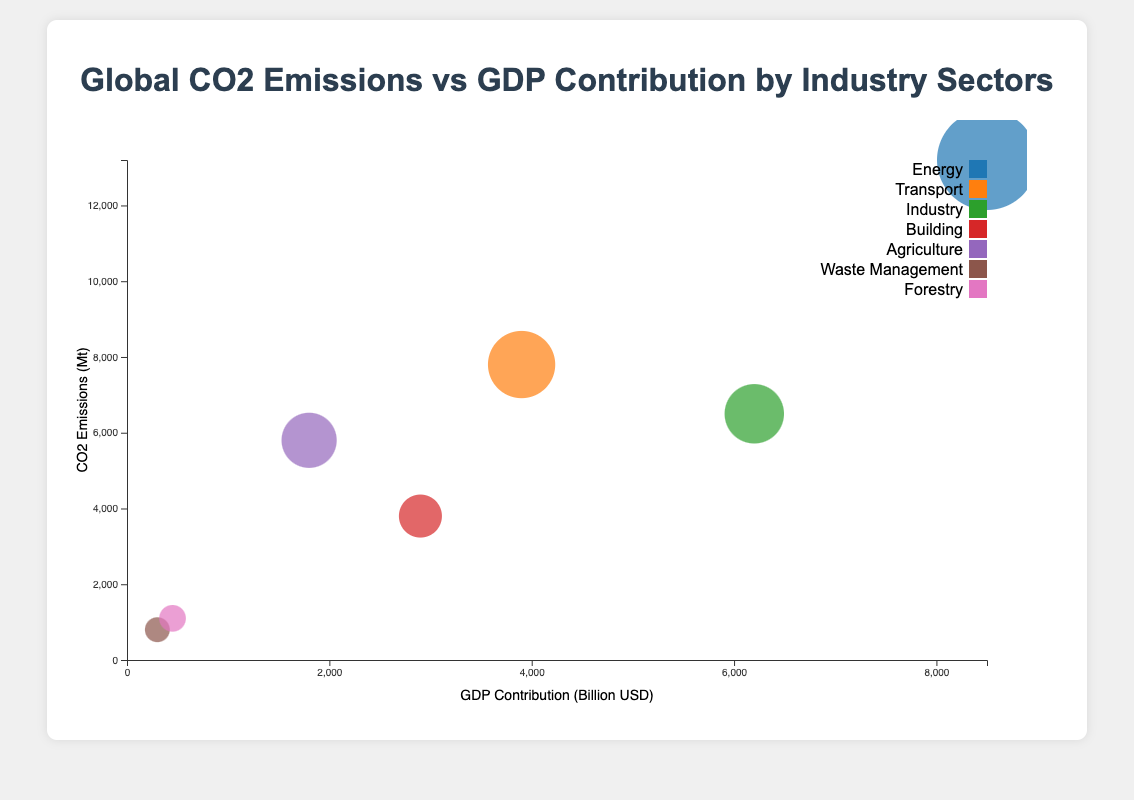What sector has the highest CO2 emissions? The sector with the highest bubble (circle) on the vertical axis represents the sector with the highest CO2 emissions. From the chart, we can see that the "Energy" sector has the highest bubble on the y-axis.
Answer: Energy What is the GDP contribution of the sector with the lowest CO2 emissions? The sector with the smallest bubble on the vertical axis represents the sector with the lowest CO2 emissions. From the chart, the "Waste Management" sector has the lowest CO2 emissions, and its corresponding bubble on the x-axis shows a GDP contribution of $300 billion.
Answer: 300 billion USD Which two sectors have similar CO2 emissions but different GDP contributions? We need to identify sectors whose bubbles are at almost the same vertical level but differ significantly horizontally. The sectors "Industry" and "Agriculture" have similar CO2 emissions (6500 Mt and 5800 Mt, respectively), but their GDP contributions are quite different (6200 billion USD and 1800 billion USD, respectively).
Answer: Industry and Agriculture What sector has the largest bubble size and what does it indicate? The largest bubble size indicates the highest CO2 emissions. By observing the clusters in the chart, the sector "Energy" has the largest bubble size.
Answer: Energy Which sector has the highest GDP contribution and what are its CO2 emissions? The sector with the furthest bubble to the right on the x-axis has the highest GDP contribution. The "Energy" sector, located furthest to the right, has a GDP contribution of 8500 billion USD and CO2 emissions of 13200 Mt seen by its vertical position.
Answer: Energy, 13200 Mt What is the average GDP contribution of the sectors with CO2 emissions greater than 5000 Mt? Sectors with emissions greater than 5000 Mt are "Energy," "Transport," and "Agriculture." Their GDP contributions are 8500, 3900, and 1800 billion USD, respectively. The average GDP contribution is calculated as (8500 + 3900 + 1800) / 3.
Answer: 4733.33 billion USD Compare the GDP contribution of the Transport sector to the Industry sector. The GDP contributions of the Transport and Industry sectors can be identified by their horizontal positions. The Transport sector has a GDP contribution of 3900 billion USD, while the Industry sector has a GDP contribution of 6200 billion USD. Comparing these two data points, Industry's GDP contribution is higher.
Answer: Industry sector has higher GDP contribution If we combined the CO2 emissions from Waste Management and Forestry, what would be their total CO2 emissions? The CO2 emissions for Waste Management and Forestry are 800 Mt and 1100 Mt, respectively. Summing these values gives a total of 800 + 1100.
Answer: 1900 Mt What is the difference in GDP contribution between the Building sector and the Transport sector? The GDP contributions for the Building and Transport sectors can be found from their horizontal positions on the chart. The Building sector has a GDP contribution of 2900 billion USD, while the Transport sector has a GDP contribution of 3900 billion USD. The difference is 3900 - 2900.
Answer: 1000 billion USD 